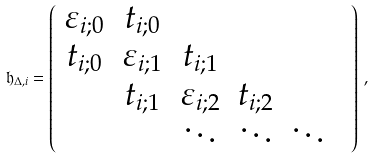Convert formula to latex. <formula><loc_0><loc_0><loc_500><loc_500>\mathfrak { h } _ { \Delta , i } = \left ( \begin{array} { c c c c c c } \varepsilon _ { i ; 0 } & t _ { i ; 0 } & & & & \\ t _ { i ; 0 } & \varepsilon _ { i ; 1 } & t _ { i ; 1 } & & & \\ & t _ { i ; 1 } & \varepsilon _ { i ; 2 } & t _ { i ; 2 } & & \\ & & \ddots & \ddots & \ddots & \\ \end{array} \right ) \, ,</formula> 